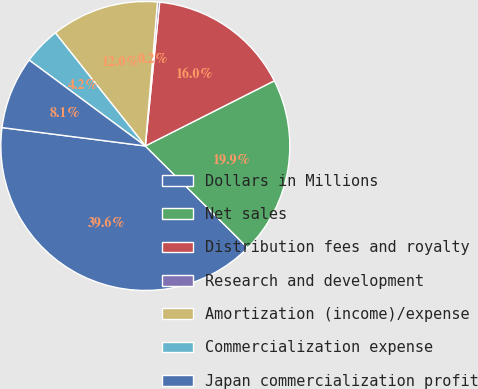Convert chart to OTSL. <chart><loc_0><loc_0><loc_500><loc_500><pie_chart><fcel>Dollars in Millions<fcel>Net sales<fcel>Distribution fees and royalty<fcel>Research and development<fcel>Amortization (income)/expense<fcel>Commercialization expense<fcel>Japan commercialization profit<nl><fcel>39.57%<fcel>19.91%<fcel>15.97%<fcel>0.24%<fcel>12.04%<fcel>4.17%<fcel>8.1%<nl></chart> 